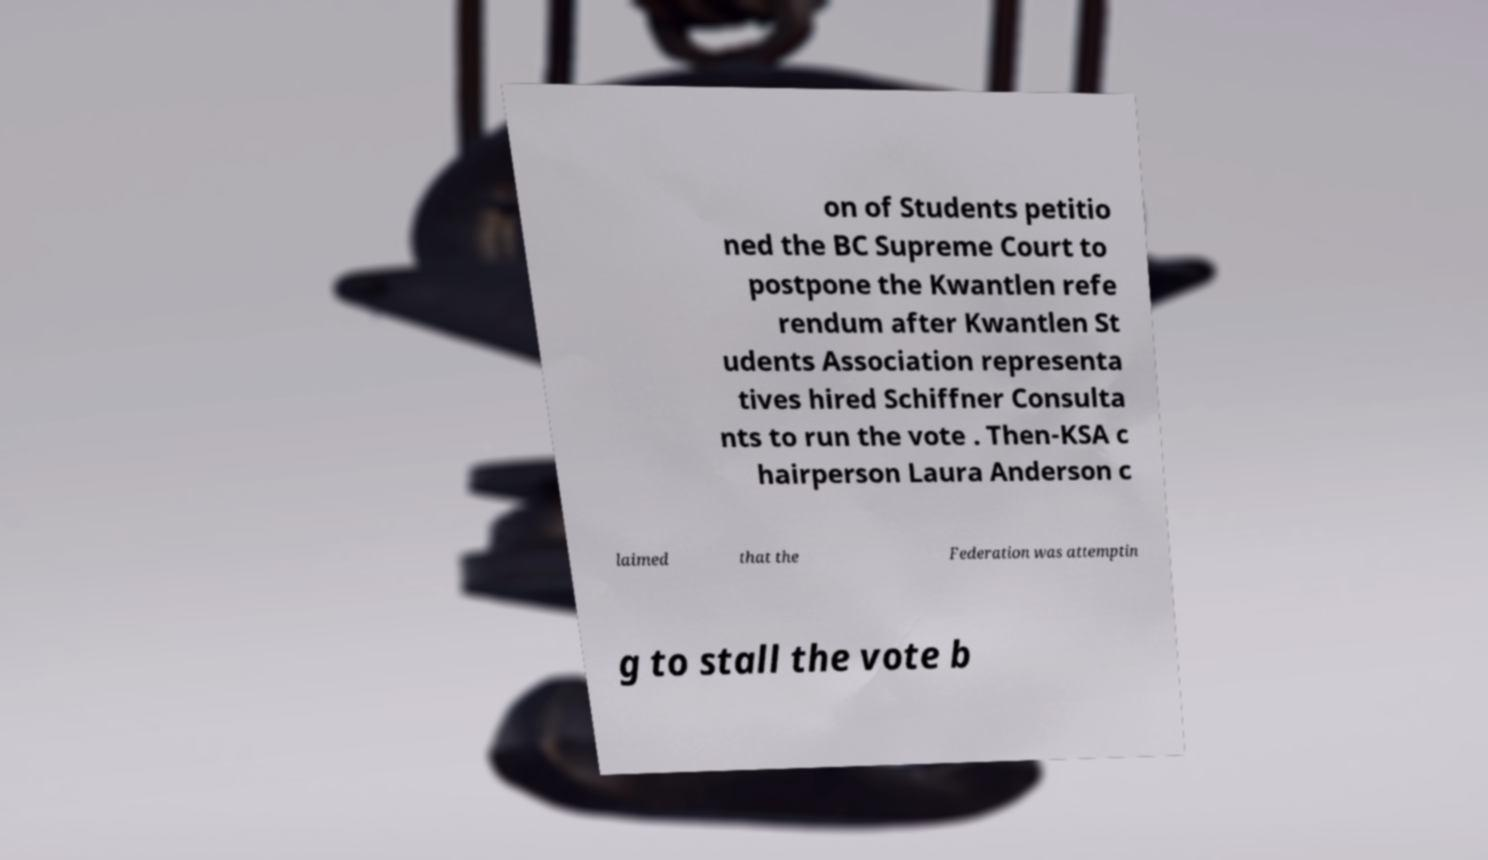Can you accurately transcribe the text from the provided image for me? on of Students petitio ned the BC Supreme Court to postpone the Kwantlen refe rendum after Kwantlen St udents Association representa tives hired Schiffner Consulta nts to run the vote . Then-KSA c hairperson Laura Anderson c laimed that the Federation was attemptin g to stall the vote b 